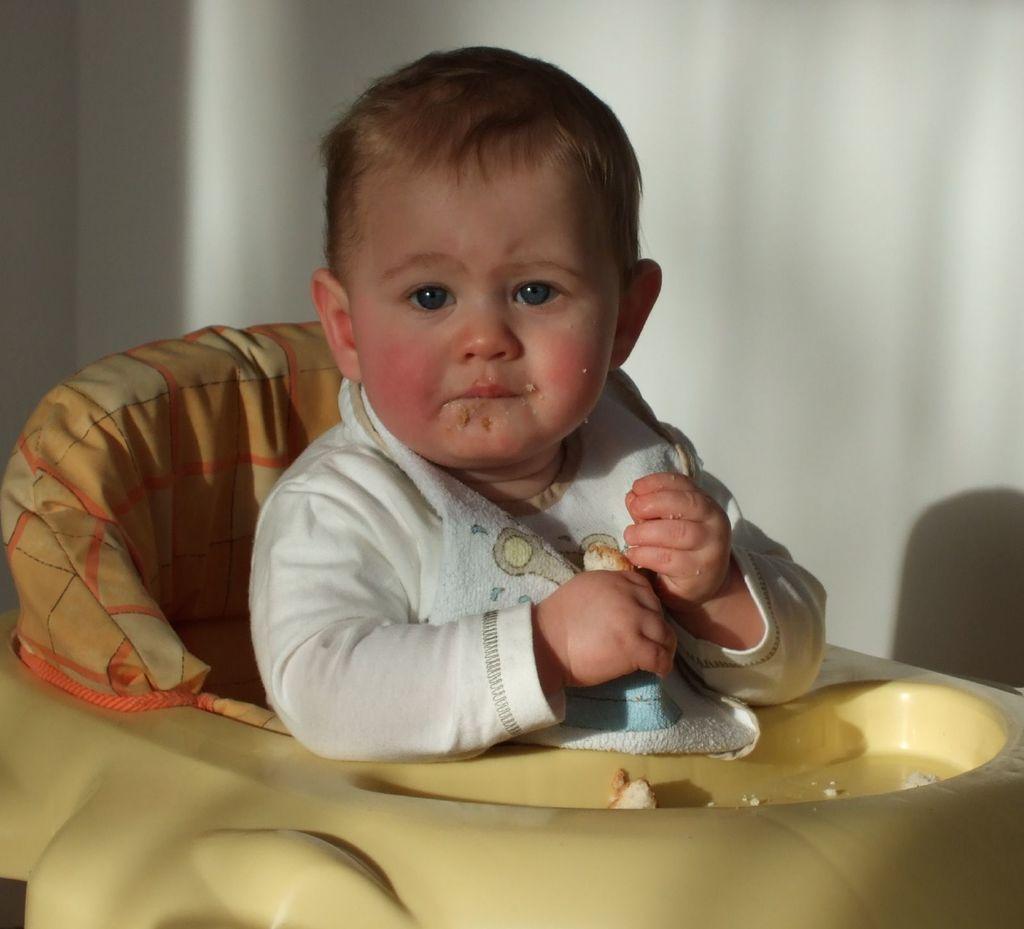Please provide a concise description of this image. In this image we can see a kid sitting on the chair. In the background there is a wall. 